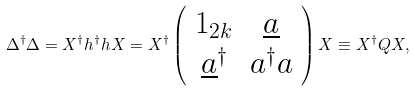<formula> <loc_0><loc_0><loc_500><loc_500>\Delta ^ { \dag } \Delta = X ^ { \dag } h ^ { \dag } h X = X ^ { \dag } \left ( \begin{array} { c c } 1 _ { 2 k } & \underline { a } \\ \underline { a } ^ { \dag } & a ^ { \dag } a \\ \end{array} \right ) X \equiv X ^ { \dag } Q X ,</formula> 